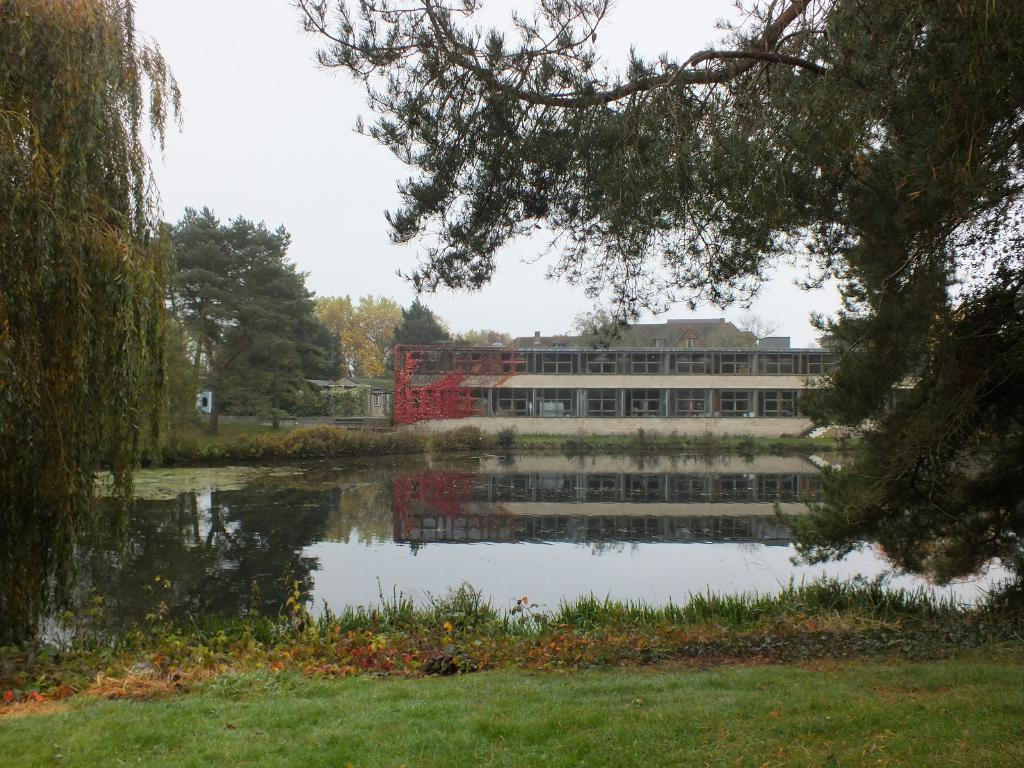What type of structure can be seen in the image? There is a building in the image. What type of vegetation is present in the image? There are trees and creepers visible in the image. What natural element can be seen in the image? Water is visible in the image. What type of ground cover is present in the image? Grass is present in the image. What type of debris can be seen in the image? Shredded leaves are visible in the image. What is visible at the bottom of the image? The ground is visible in the image. Where is the fowl taking a bath in the image? There is no fowl taking a bath in the image. What type of field is visible in the image? There is no field present in the image. 